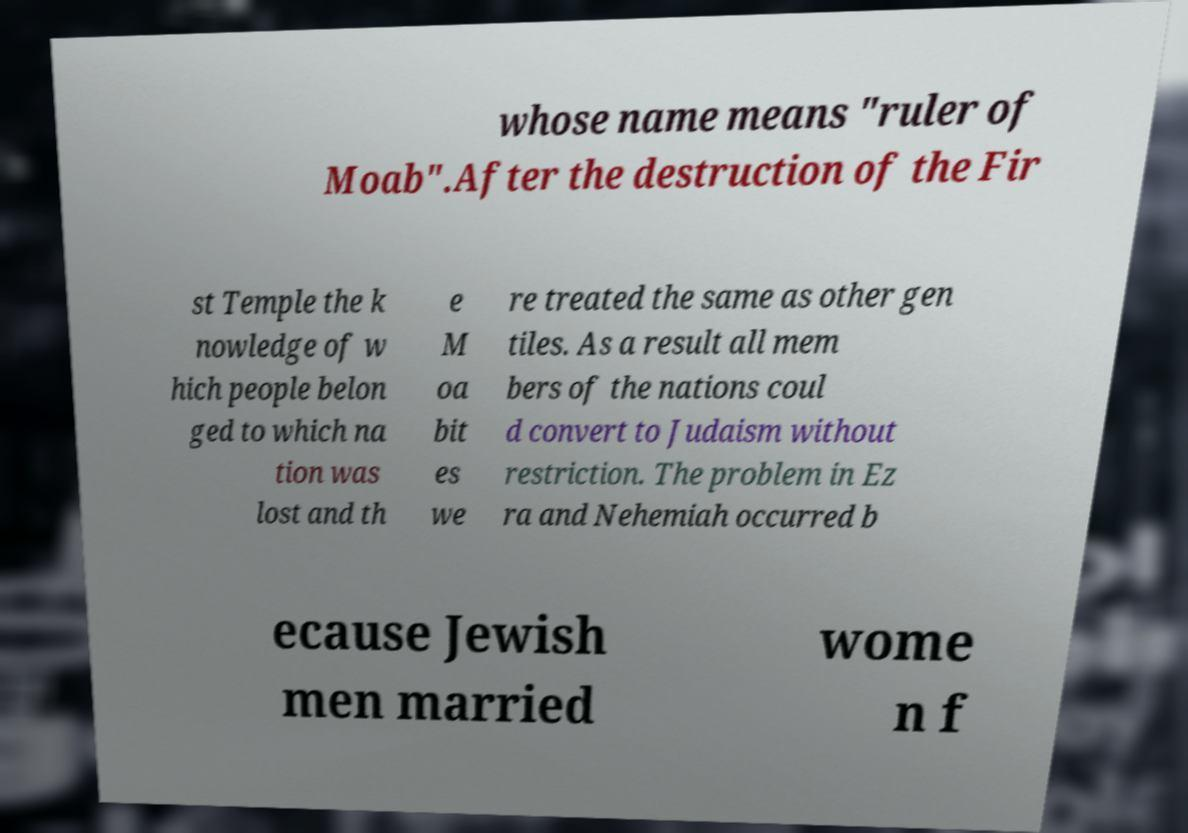Could you extract and type out the text from this image? whose name means "ruler of Moab".After the destruction of the Fir st Temple the k nowledge of w hich people belon ged to which na tion was lost and th e M oa bit es we re treated the same as other gen tiles. As a result all mem bers of the nations coul d convert to Judaism without restriction. The problem in Ez ra and Nehemiah occurred b ecause Jewish men married wome n f 